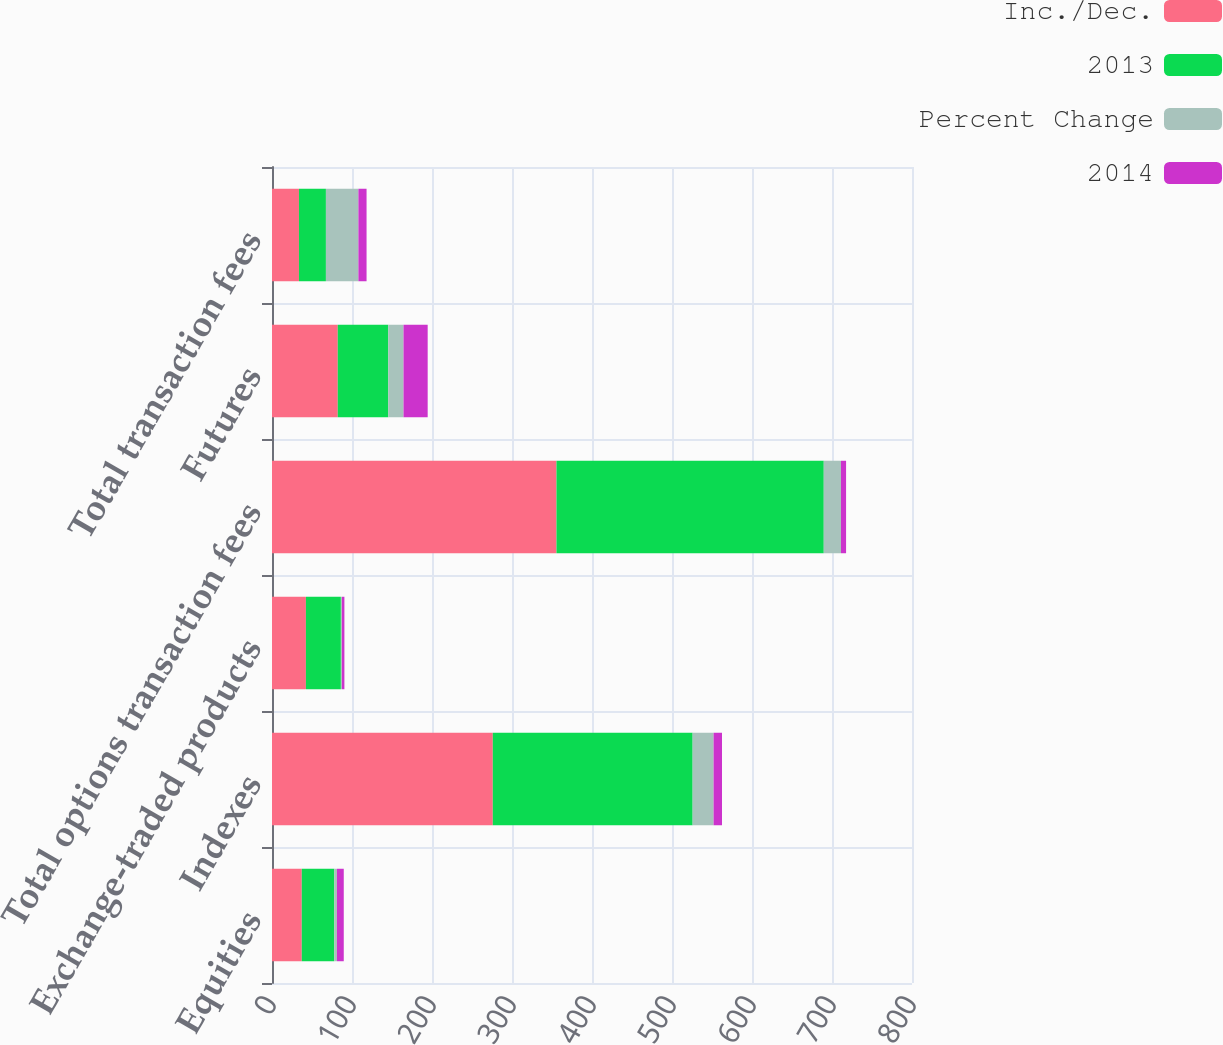Convert chart. <chart><loc_0><loc_0><loc_500><loc_500><stacked_bar_chart><ecel><fcel>Equities<fcel>Indexes<fcel>Exchange-traded products<fcel>Total options transaction fees<fcel>Futures<fcel>Total transaction fees<nl><fcel>Inc./Dec.<fcel>37.2<fcel>276<fcel>42.4<fcel>355.6<fcel>82.2<fcel>33.7<nl><fcel>2013<fcel>40.6<fcel>249.8<fcel>43.7<fcel>334.1<fcel>63.1<fcel>33.7<nl><fcel>Percent Change<fcel>3.4<fcel>26.2<fcel>1.3<fcel>21.5<fcel>19.1<fcel>40.6<nl><fcel>2014<fcel>8.5<fcel>10.5<fcel>3.1<fcel>6.4<fcel>30.2<fcel>10.2<nl></chart> 